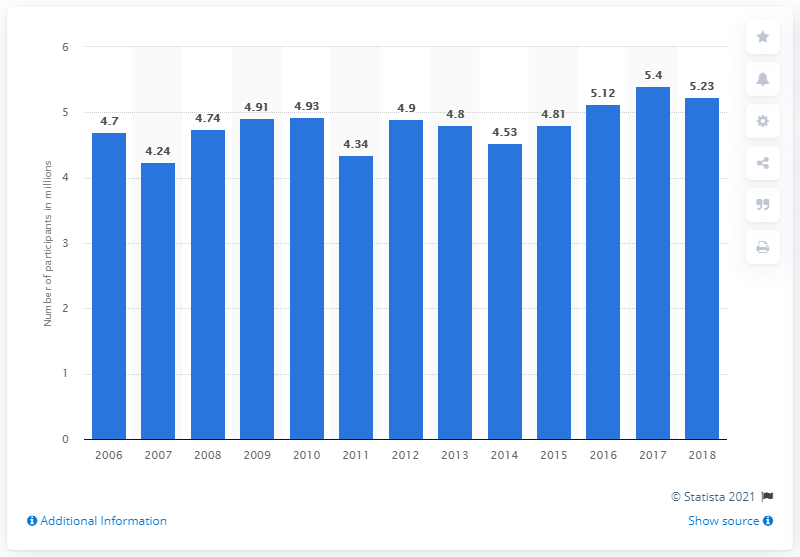Outline some significant characteristics in this image. A total of 5.23 participants were involved in indoor soccer in 2018. 